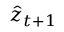<formula> <loc_0><loc_0><loc_500><loc_500>\hat { z } _ { t + 1 }</formula> 